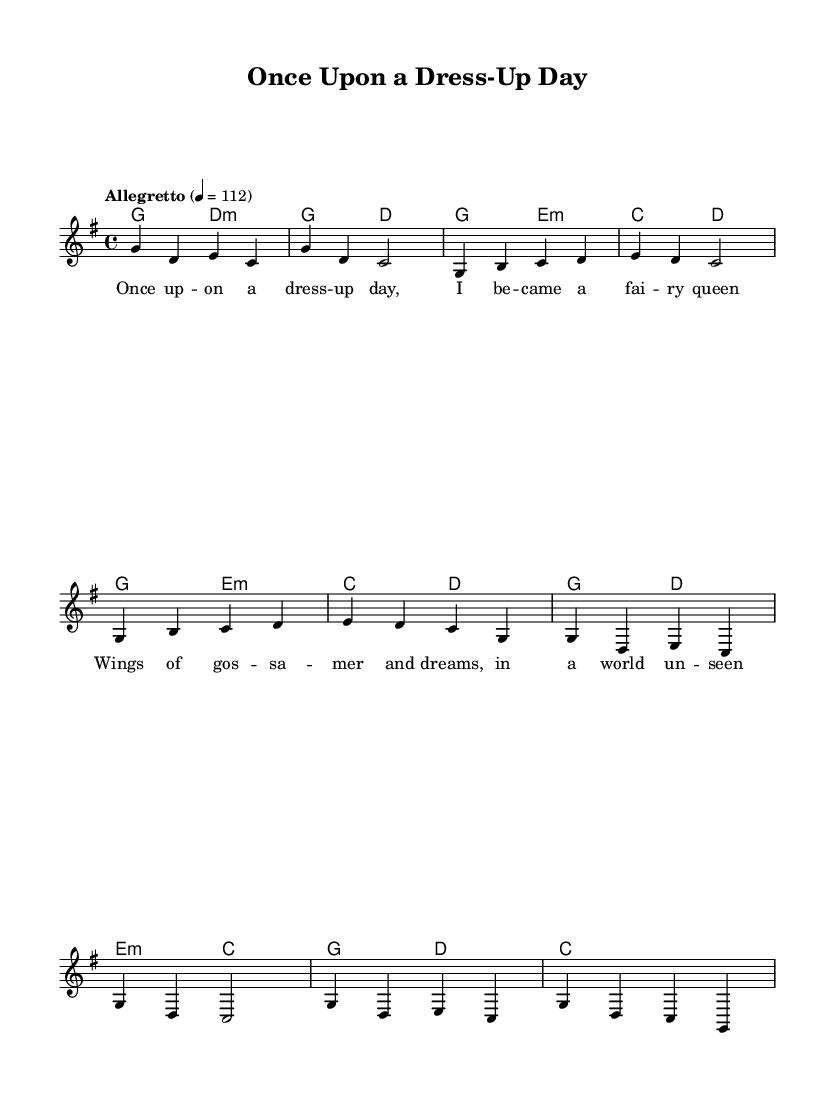What is the key signature of this music? The key signature is G major, which has one sharp (F#).
Answer: G major What is the time signature of this piece? The time signature is 4/4, indicating four beats in each measure.
Answer: 4/4 What is the tempo marking for the piece? The tempo marking indicates an Allegretto speed, specifically 112 beats per minute.
Answer: Allegretto How many measures are in the chorus section? The chorus section consists of four measures as indicated by the music notation.
Answer: Four measures What type of music fusion is this piece? The music is a whimsical folk-pop fusion, characterized by its storytelling lyrics and folk elements.
Answer: Whimsical folk-pop fusion How does the melody relate to the lyrics in the verse? The melody emphasizes the syllables of the lyrics, aligning with the natural rhythm of the storytelling.
Answer: Emphasis on storytelling What is the main thematic element present in the lyrics? The main thematic element is transformation and embodiment of fairytale characters through dress-up.
Answer: Transformation and embodiment 